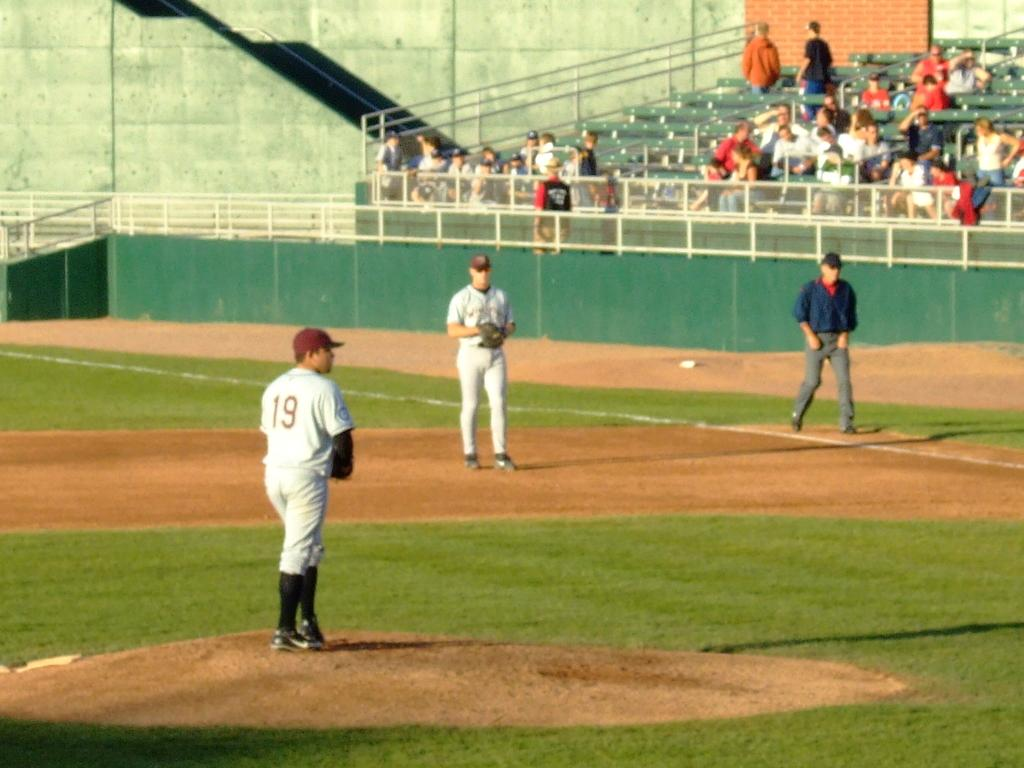Provide a one-sentence caption for the provided image. number 19 getting ready to pitch baseball in front of sparse crowd. 